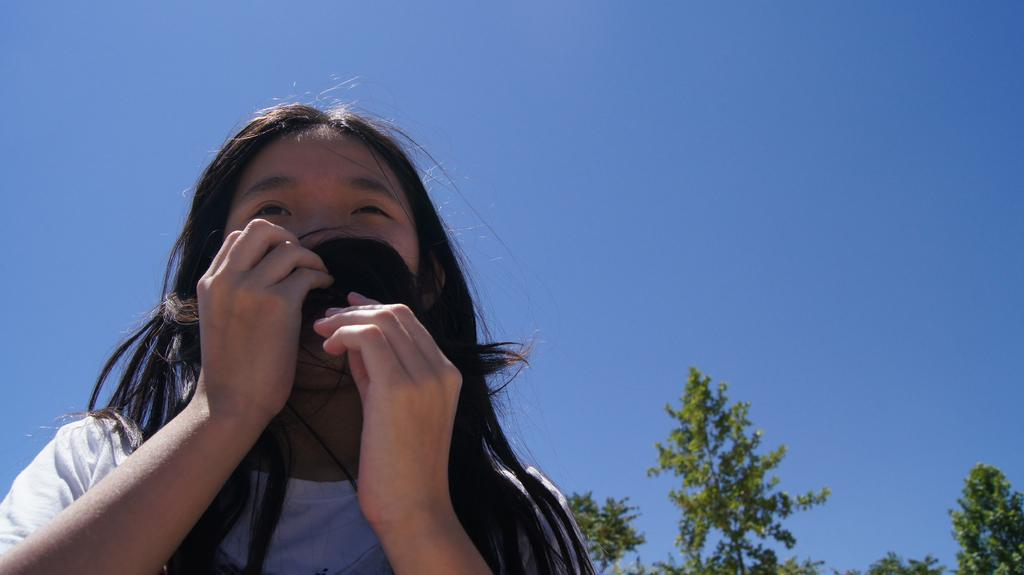Who is the main subject in the image? There is a woman in the image. What is the woman doing in the image? The woman is holding her hair. What can be seen in the background of the image? The sky is visible in the background of the image. What type of vegetation is present at the bottom right of the image? There are leaves on the right side bottom of the image. What type of pin is the woman using to hold her hair in the image? There is no pin visible in the image; the woman is simply holding her hair with her hand. 